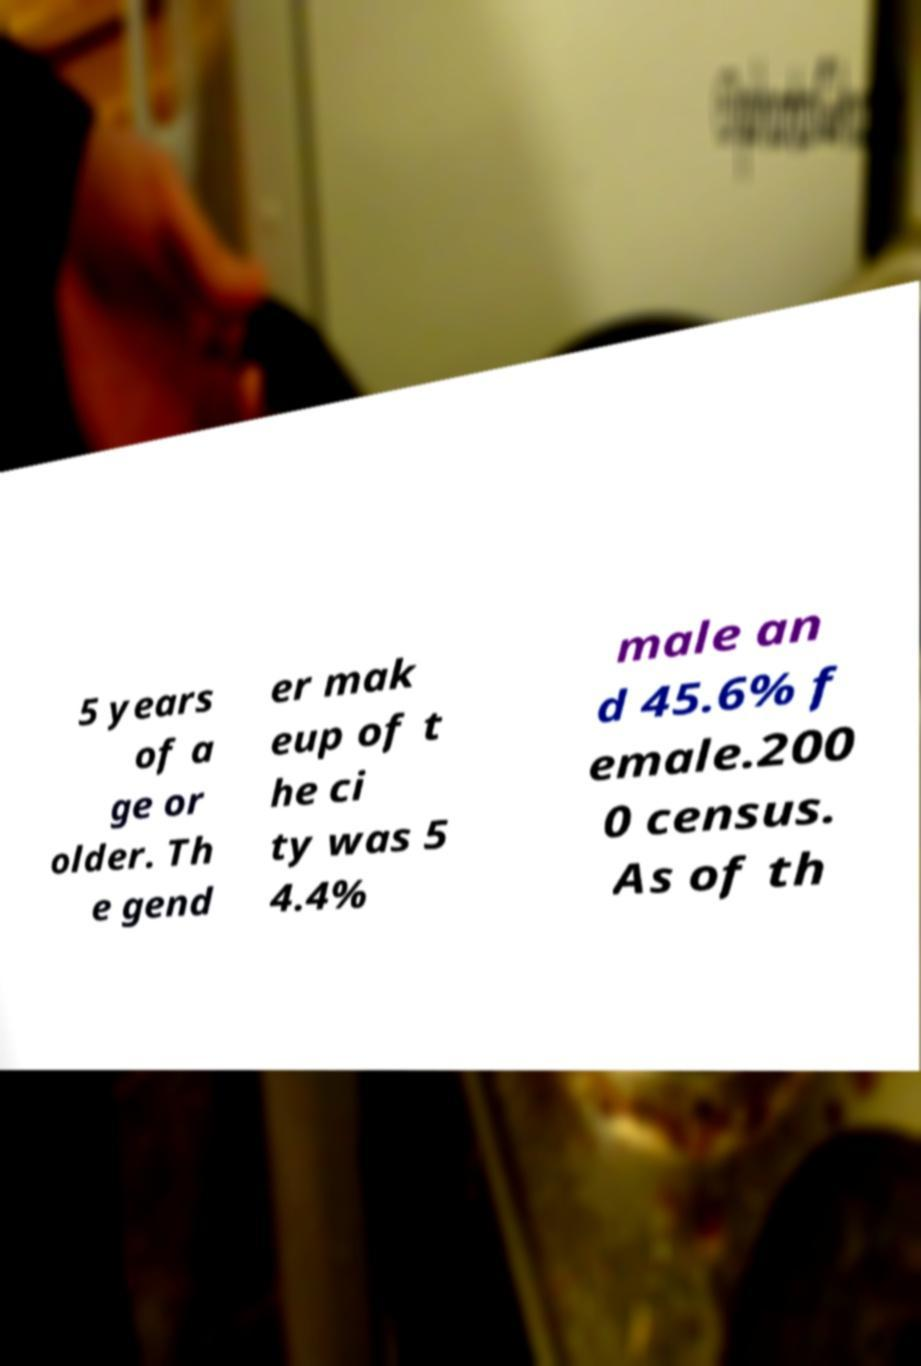For documentation purposes, I need the text within this image transcribed. Could you provide that? 5 years of a ge or older. Th e gend er mak eup of t he ci ty was 5 4.4% male an d 45.6% f emale.200 0 census. As of th 